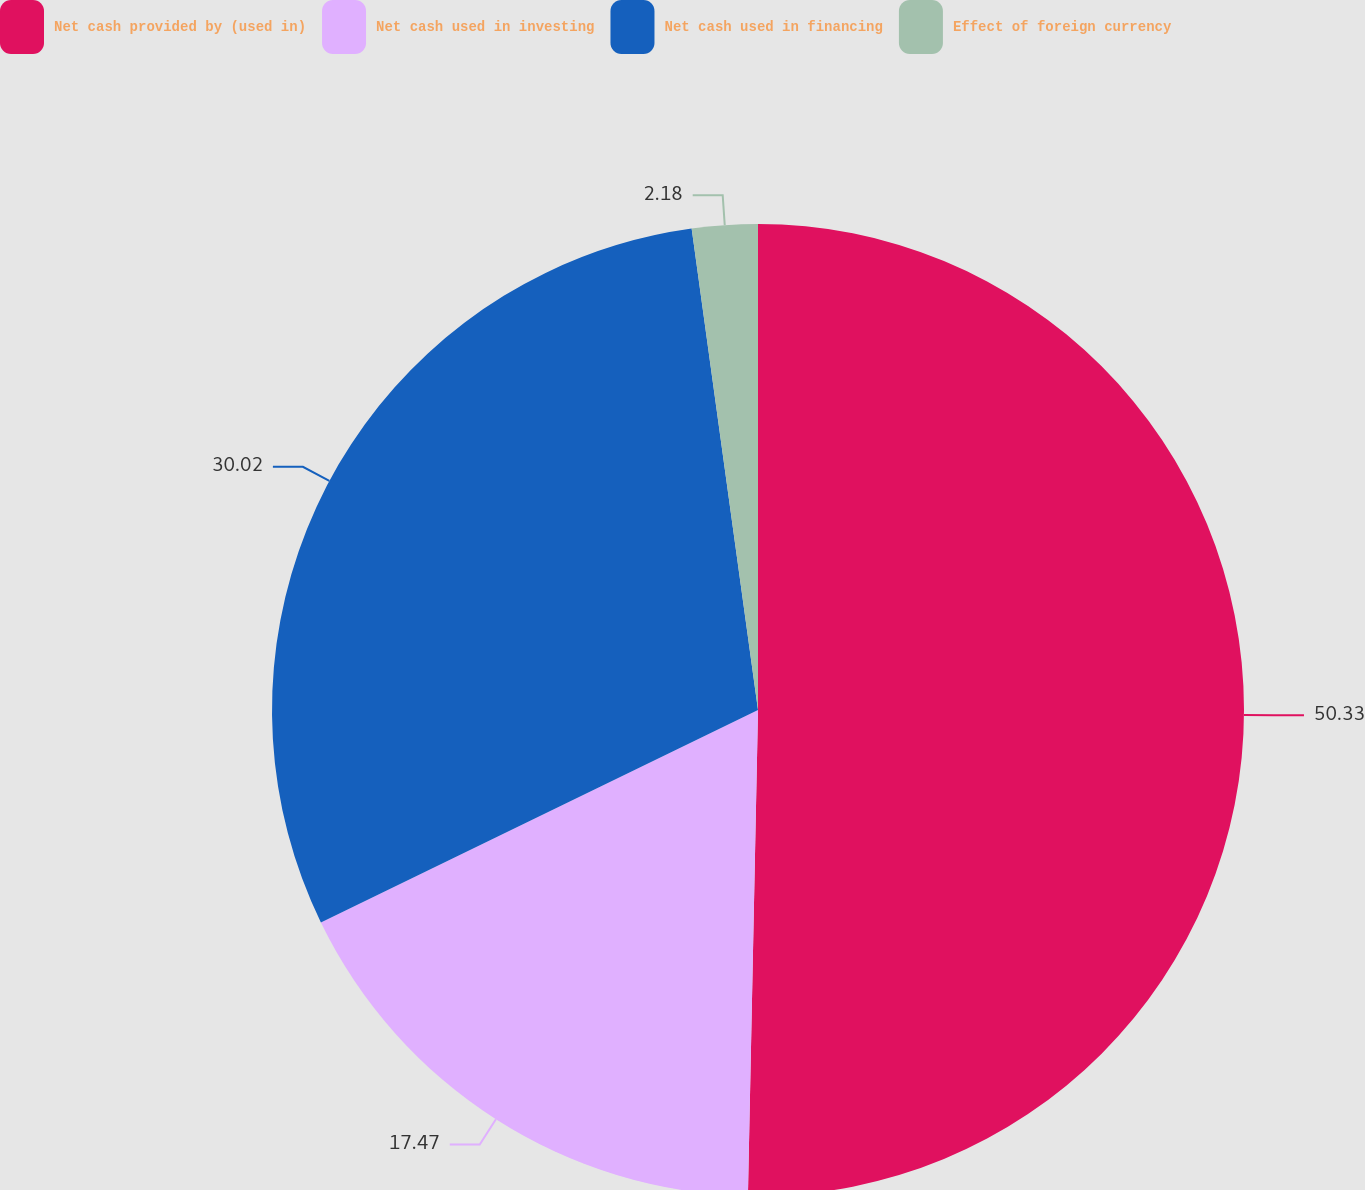<chart> <loc_0><loc_0><loc_500><loc_500><pie_chart><fcel>Net cash provided by (used in)<fcel>Net cash used in investing<fcel>Net cash used in financing<fcel>Effect of foreign currency<nl><fcel>50.33%<fcel>17.47%<fcel>30.02%<fcel>2.18%<nl></chart> 